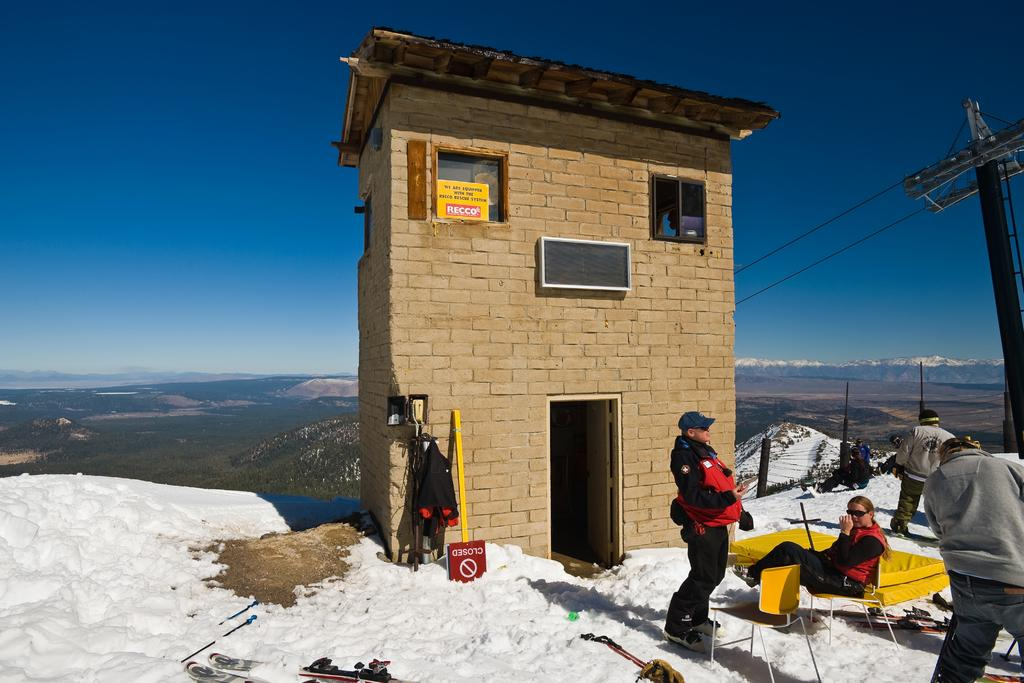What is the weather like in the image? There is snow in the image, indicating a cold and wintry weather. What type of structure is present in the image? There is a house in the image. What features does the house have? The house has windows and a door. What type of furniture is visible in the image? There is a bed and chairs in the image. Who is present in the image? There are people in the image. What is the purpose of the current pole in the image? The current pole is likely used for providing electricity to the house. What is visible at the top of the image? The sky is visible at the top of the image. What account number is associated with the lead in the image? There is no mention of an account number or lead in the image; it features snow, a house, a bed, chairs, people, a current pole, and a visible sky. What type of curve can be seen in the image? There is no curve present in the image; it features snow, a house, a bed, chairs, people, a current pole, and a visible sky. 